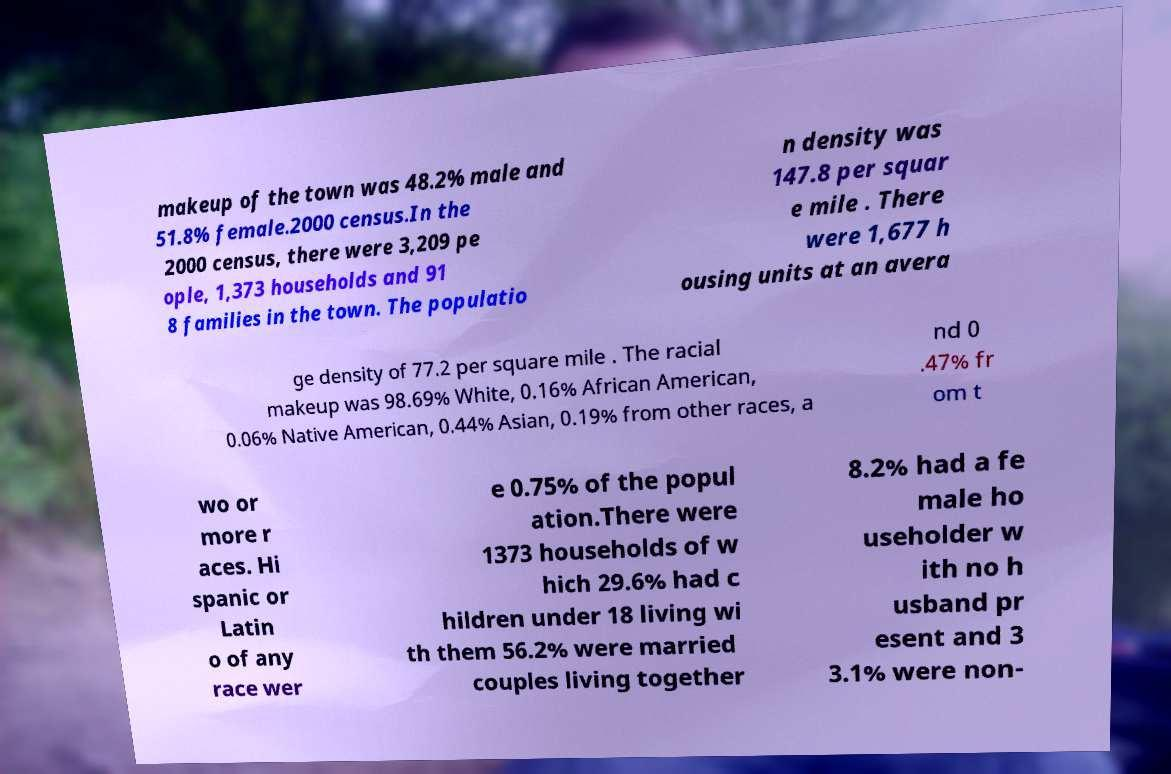For documentation purposes, I need the text within this image transcribed. Could you provide that? makeup of the town was 48.2% male and 51.8% female.2000 census.In the 2000 census, there were 3,209 pe ople, 1,373 households and 91 8 families in the town. The populatio n density was 147.8 per squar e mile . There were 1,677 h ousing units at an avera ge density of 77.2 per square mile . The racial makeup was 98.69% White, 0.16% African American, 0.06% Native American, 0.44% Asian, 0.19% from other races, a nd 0 .47% fr om t wo or more r aces. Hi spanic or Latin o of any race wer e 0.75% of the popul ation.There were 1373 households of w hich 29.6% had c hildren under 18 living wi th them 56.2% were married couples living together 8.2% had a fe male ho useholder w ith no h usband pr esent and 3 3.1% were non- 